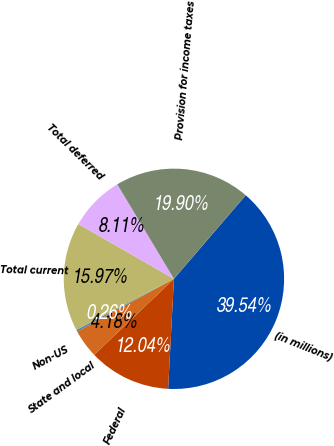Convert chart. <chart><loc_0><loc_0><loc_500><loc_500><pie_chart><fcel>(in millions)<fcel>Federal<fcel>State and local<fcel>Non-US<fcel>Total current<fcel>Total deferred<fcel>Provision for income taxes<nl><fcel>39.54%<fcel>12.04%<fcel>4.18%<fcel>0.26%<fcel>15.97%<fcel>8.11%<fcel>19.9%<nl></chart> 